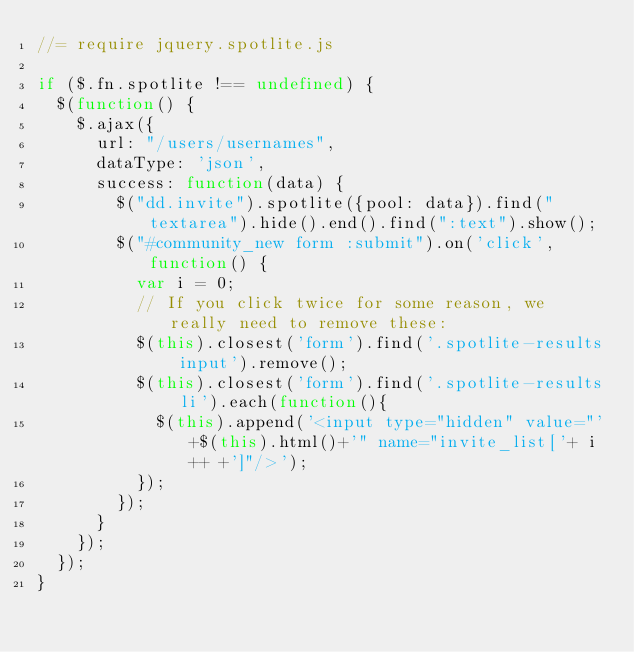<code> <loc_0><loc_0><loc_500><loc_500><_JavaScript_>//= require jquery.spotlite.js

if ($.fn.spotlite !== undefined) {
  $(function() {
    $.ajax({
      url: "/users/usernames",
      dataType: 'json',
      success: function(data) {
        $("dd.invite").spotlite({pool: data}).find("textarea").hide().end().find(":text").show();
        $("#community_new form :submit").on('click', function() {
          var i = 0;
          // If you click twice for some reason, we really need to remove these:
          $(this).closest('form').find('.spotlite-results input').remove();
          $(this).closest('form').find('.spotlite-results li').each(function(){
            $(this).append('<input type="hidden" value="'+$(this).html()+'" name="invite_list['+ i++ +']"/>');
          });
        });
      }
    });
  });
}

</code> 